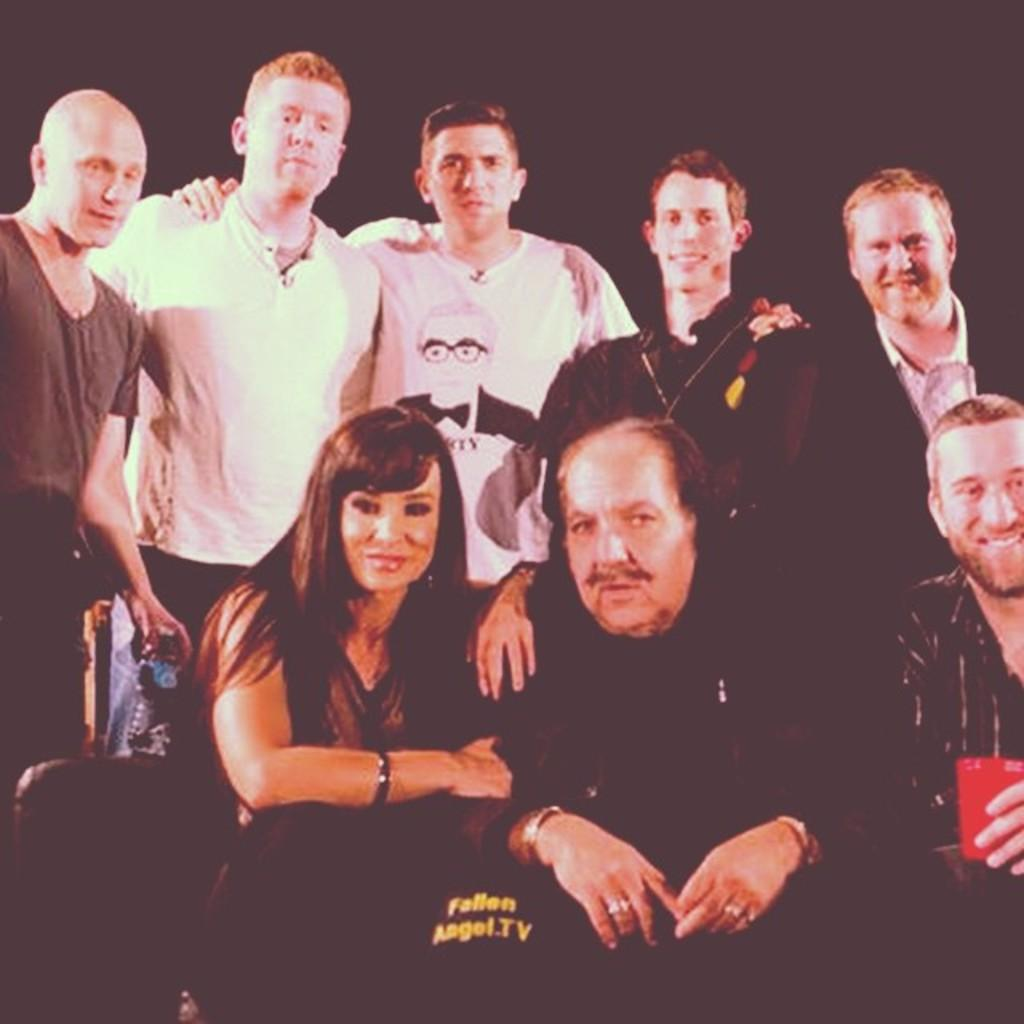How many people are in the image? There is a group of people in the image, but the exact number is not specified. What can be observed about the background of the image? The background of the image is dark. What type of experience can be gained from climbing the volcano in the image? There is no volcano present in the image, so it is not possible to gain any experience from climbing it. What type of sail can be seen in the image? There is no sail present in the image. 